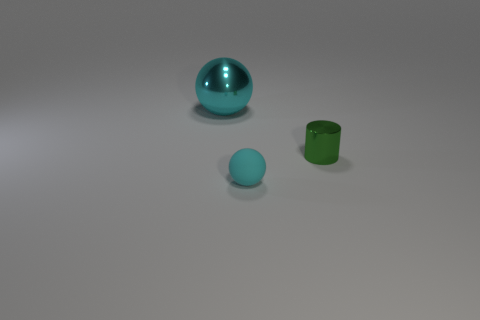Add 3 small rubber objects. How many objects exist? 6 Subtract all cylinders. How many objects are left? 2 Add 1 tiny blue cylinders. How many tiny blue cylinders exist? 1 Subtract 0 green spheres. How many objects are left? 3 Subtract all brown cylinders. Subtract all green shiny things. How many objects are left? 2 Add 3 cylinders. How many cylinders are left? 4 